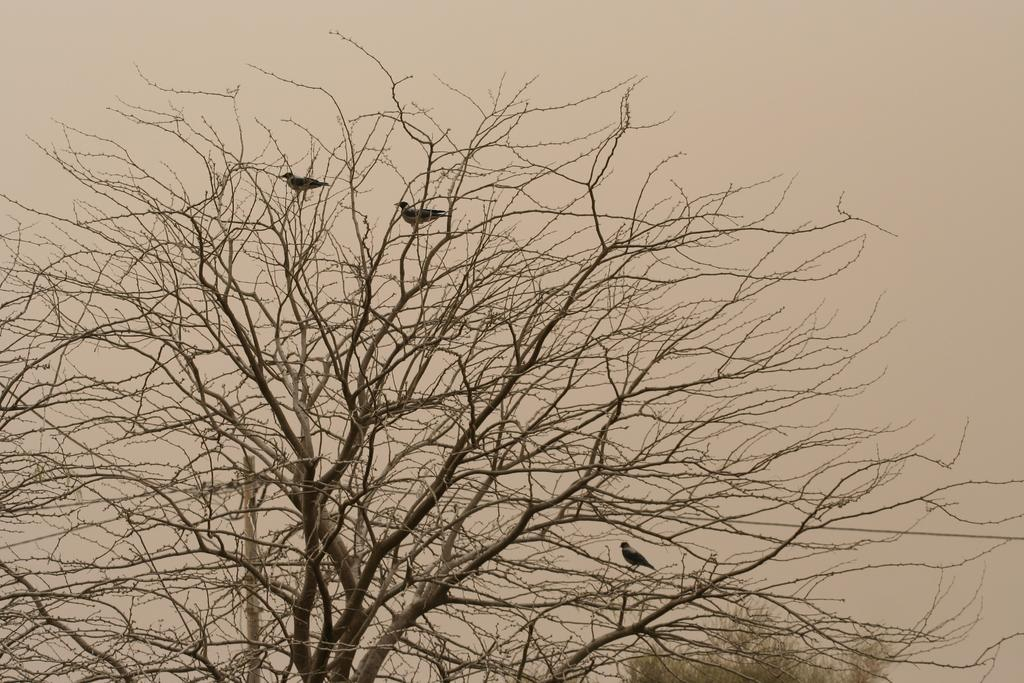What animals can be seen in the foreground of the image? There are three birds on a tree in the foreground of the image. What is the condition of the tree in the foreground? The tree in the foreground has no leaves. What can be seen in the background of the image? There is a pole and another tree in the background of the image, as well as the sky. What type of soup is being served to the woman in the image? There is no woman or soup present in the image; it features three birds on a tree and a pole in the background. 